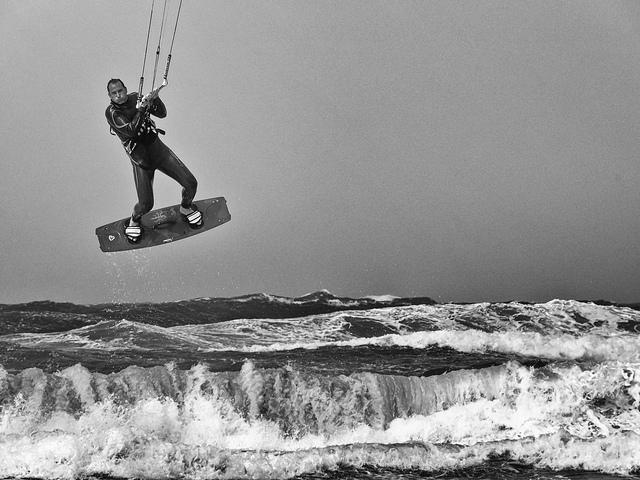How many feet in the air is this man?
Answer briefly. 5. Is this at a beach?
Keep it brief. Yes. Is this photo colorful?
Short answer required. No. Is he hang gliding?
Keep it brief. No. 